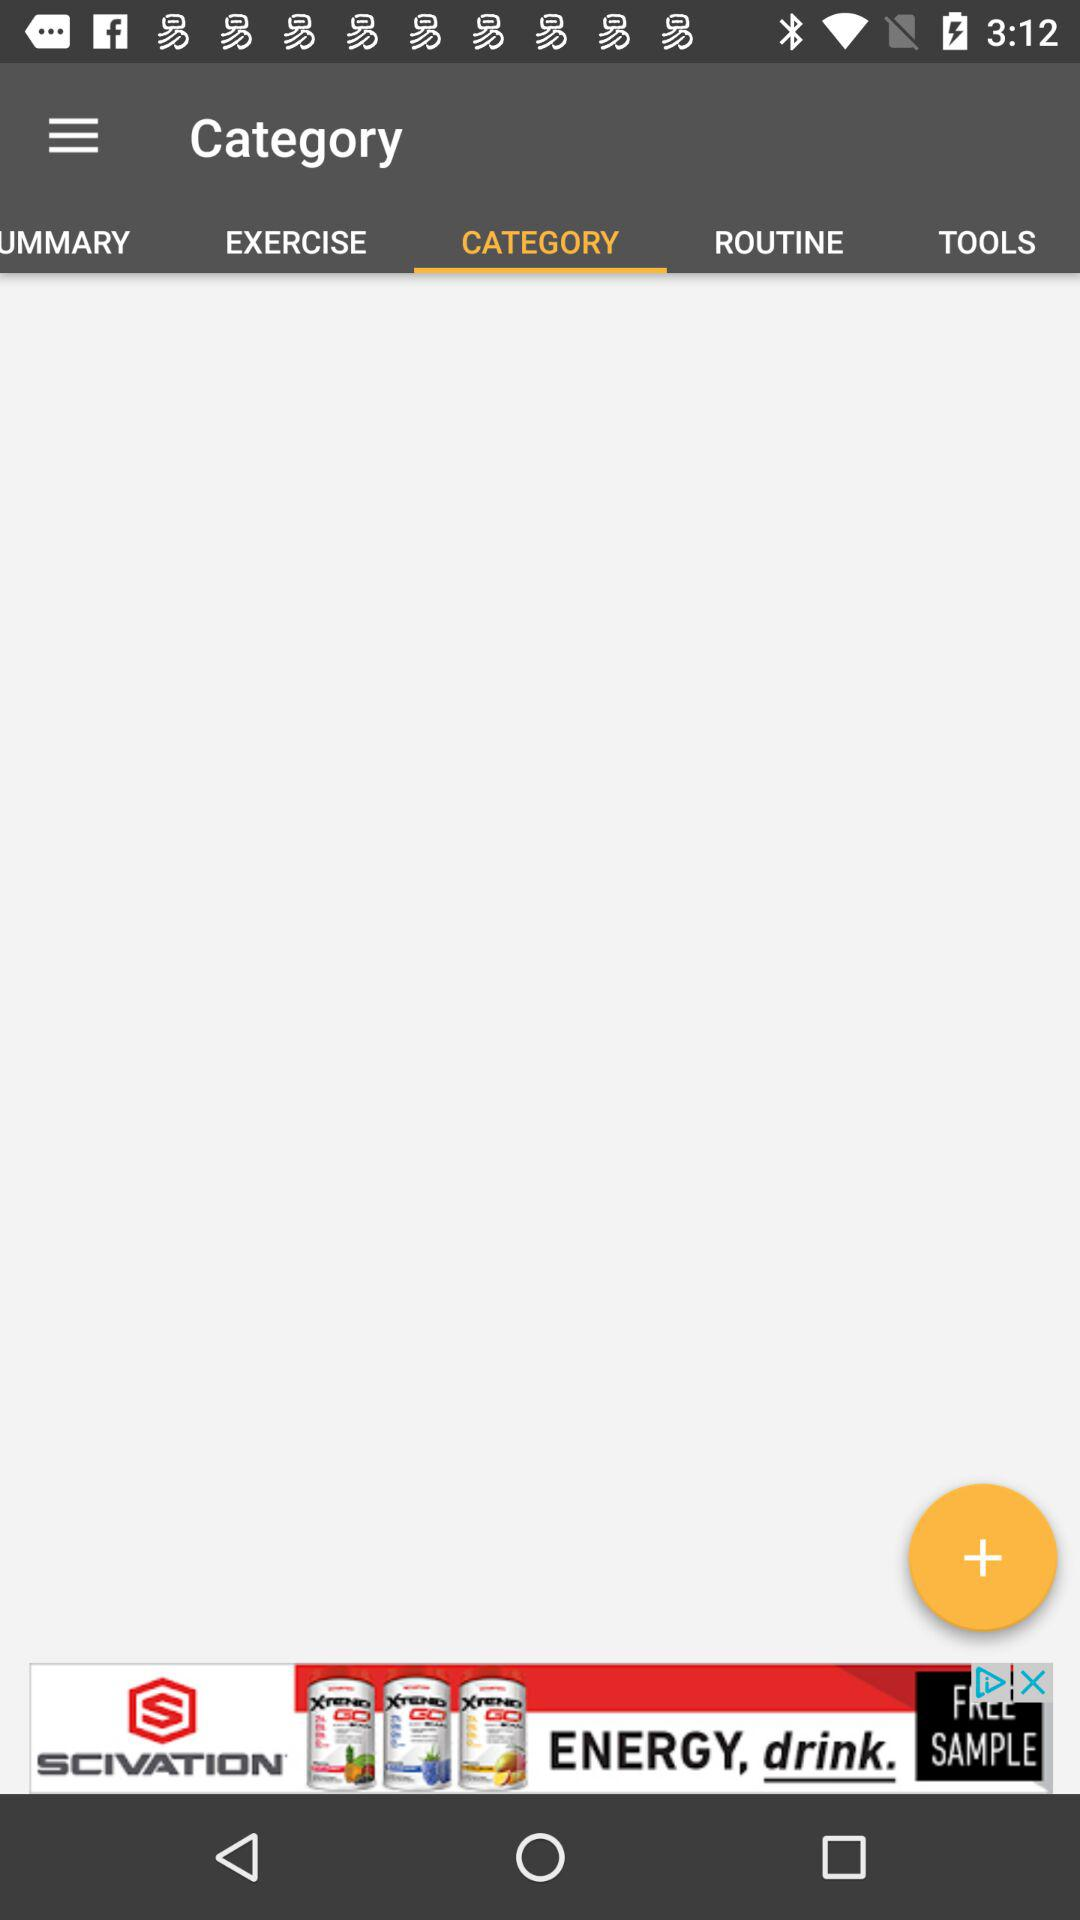Which tab is selected? The selected tab is "CATEGORY". 